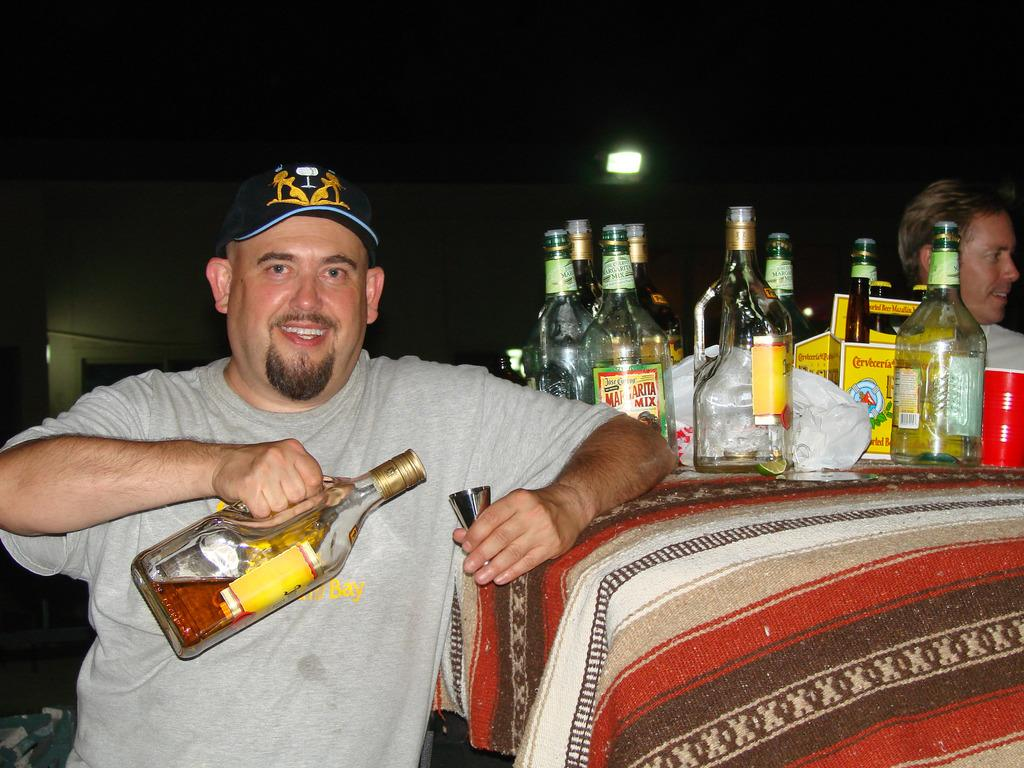What is the man in the image doing? The man is standing in the image and holding a wine bottle in his hands. What else can be seen in the image besides the man? There are many bottles visible in the image. Can you describe the light in the image? There is a light in the image, but its specific characteristics are not mentioned in the facts. What type of hat is the person wearing in the image? There is no person wearing a hat in the image; the only person mentioned is the man holding a wine bottle, and no hat is mentioned. 